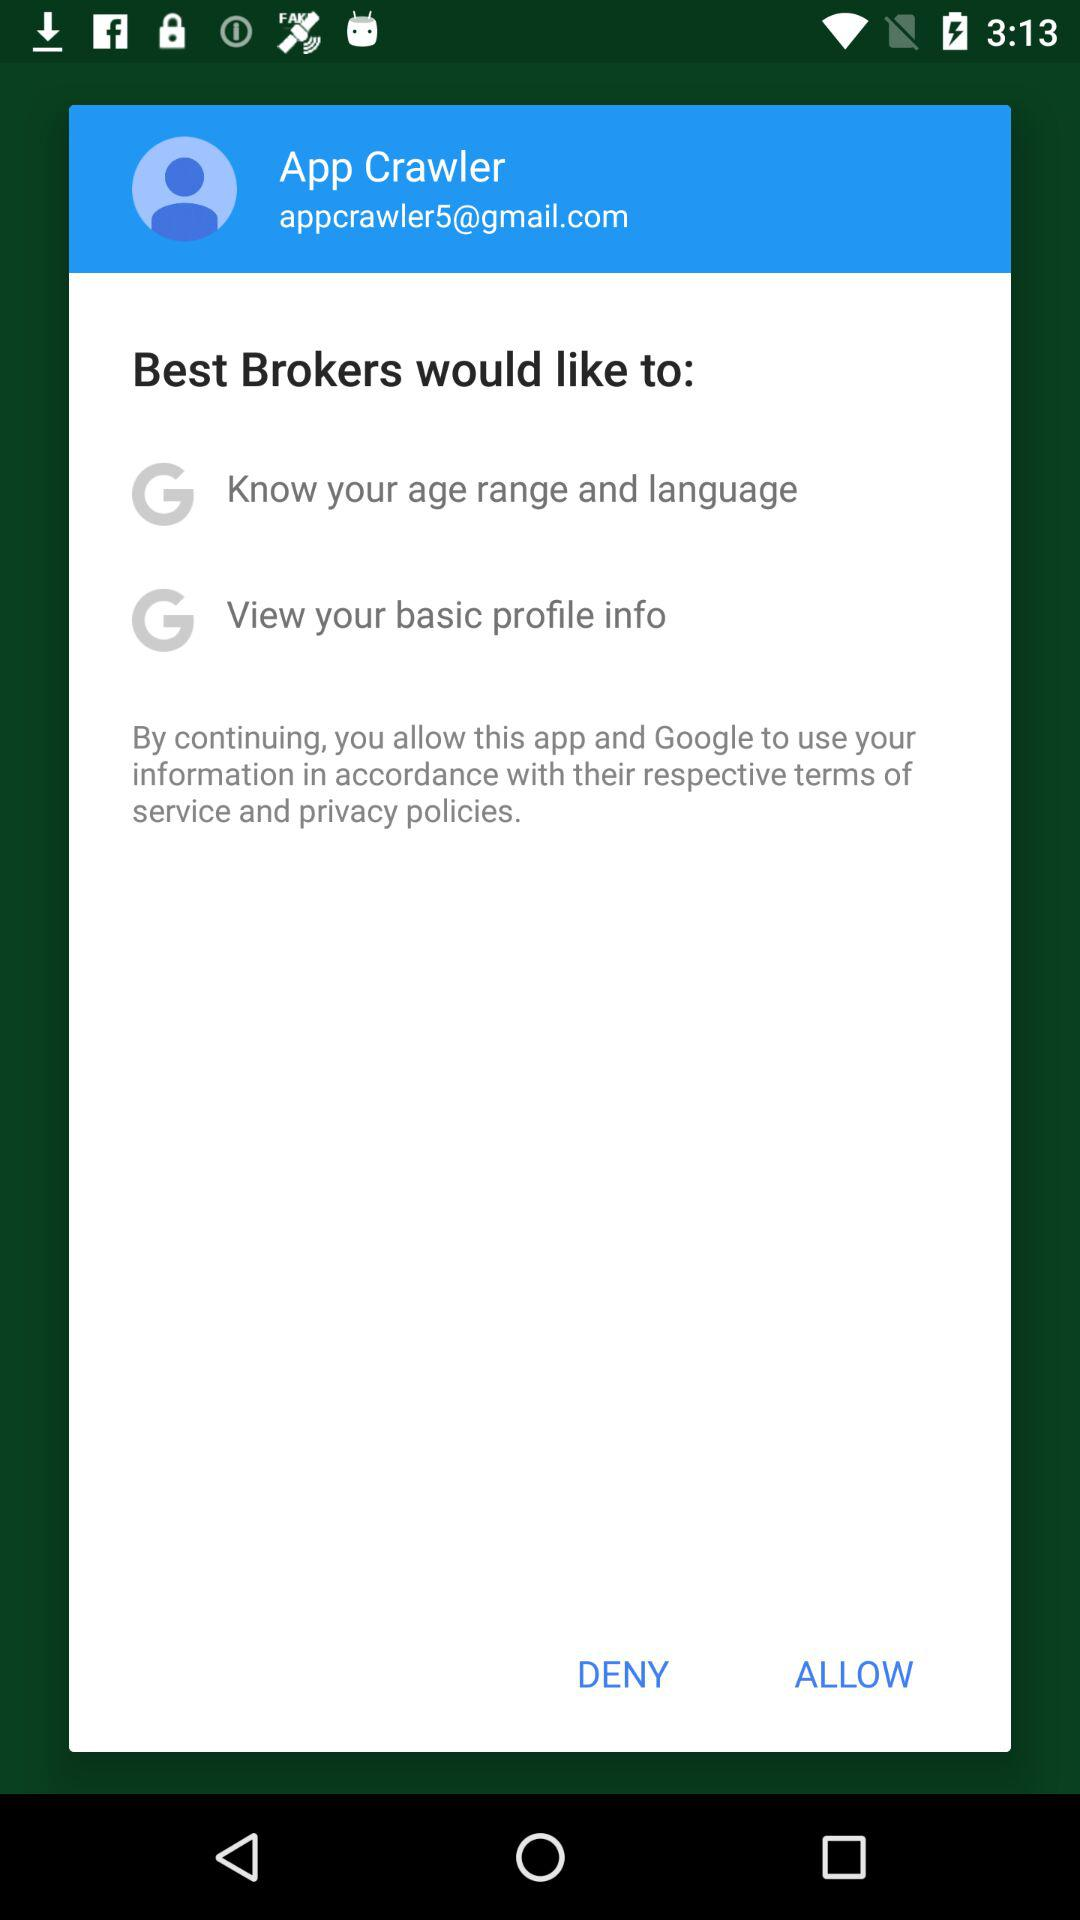What is the name of the user? The name of the user is App Crawler. 